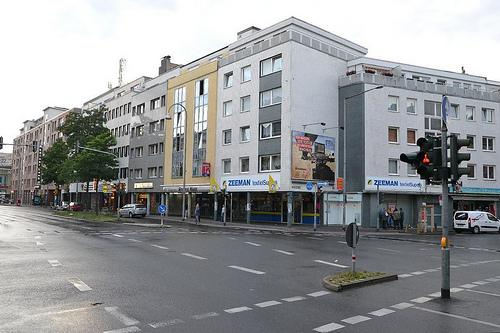Question: what letter does the name of the only business that can be seen start with?
Choices:
A. Q.
B. P.
C. H.
D. Z.
Answer with the letter. Answer: D Question: where is the silver car parked?
Choices:
A. At the school.
B. In front of the red barn.
C. Next to the trees.
D. On the street.
Answer with the letter. Answer: C Question: where is the yellow walk button?
Choices:
A. On the light pole.
B. On a box.
C. On the traffic light pole.
D. On the sidewalk.
Answer with the letter. Answer: C Question: where is the grass?
Choices:
A. Across the road.
B. Behind the fence.
C. Next to the sidewalk.
D. Under the trees and the round sign.
Answer with the letter. Answer: D Question: where are the trees?
Choices:
A. In front of the middle building.
B. Behind the fence.
C. Across the street.
D. Behind the buildings.
Answer with the letter. Answer: A Question: where is this picture taken?
Choices:
A. Street.
B. Intersection.
C. Downtown.
D. In a city.
Answer with the letter. Answer: B 